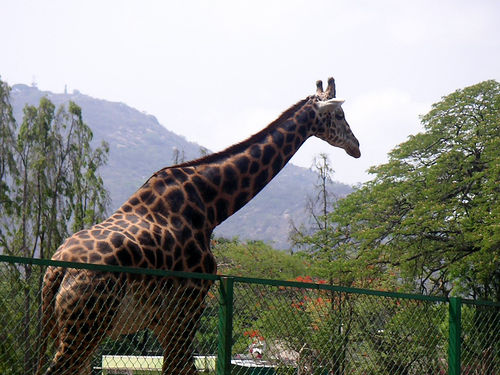How many giraffes are in the image? There is one giraffe visible in the image, standing tall against the backdrop of a clear sky with vegetation and hills in the distance. 